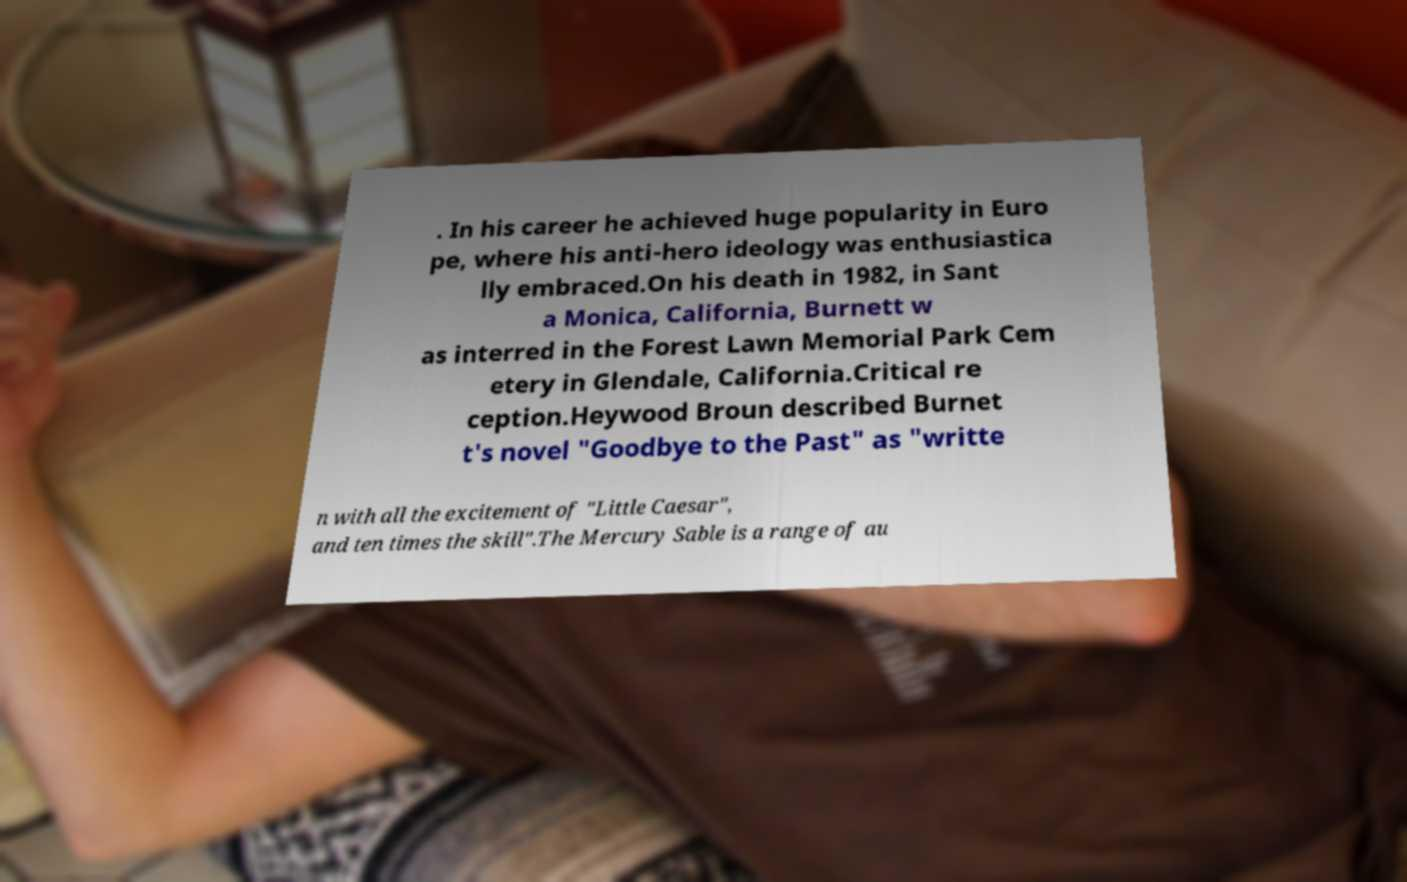For documentation purposes, I need the text within this image transcribed. Could you provide that? . In his career he achieved huge popularity in Euro pe, where his anti-hero ideology was enthusiastica lly embraced.On his death in 1982, in Sant a Monica, California, Burnett w as interred in the Forest Lawn Memorial Park Cem etery in Glendale, California.Critical re ception.Heywood Broun described Burnet t's novel "Goodbye to the Past" as "writte n with all the excitement of "Little Caesar", and ten times the skill".The Mercury Sable is a range of au 